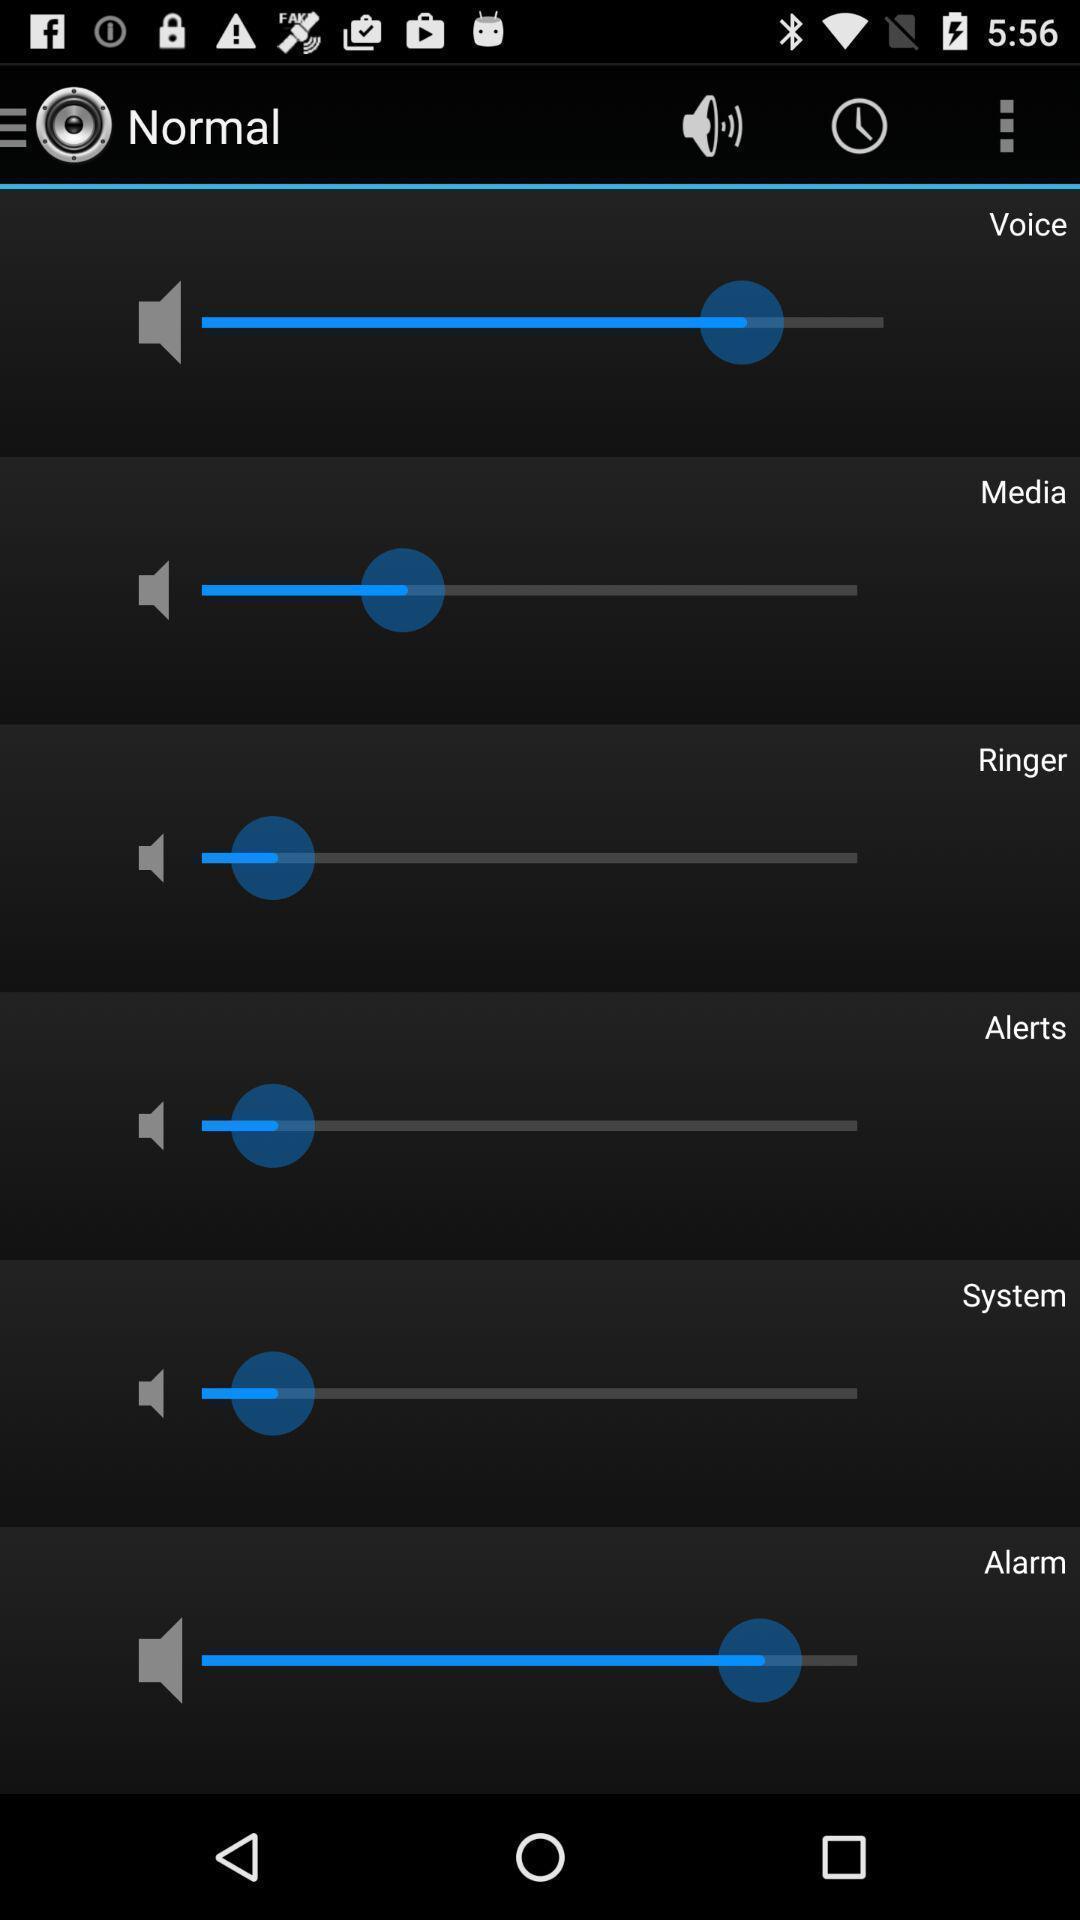Describe this image in words. Volume settings page. 